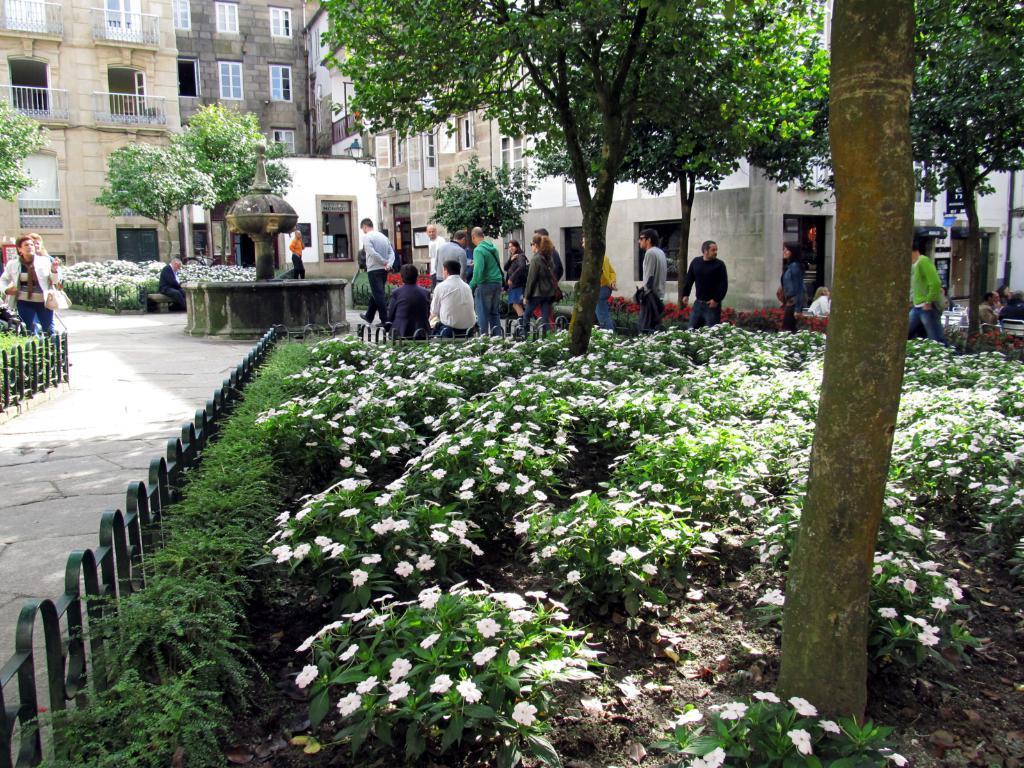In one or two sentences, can you explain what this image depicts? In this image I can see few buildings, windows, trees, few people are sitting and few people are walking. I can see few white color flowers and the fencing. 